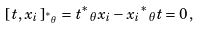Convert formula to latex. <formula><loc_0><loc_0><loc_500><loc_500>[ \, t , x _ { i } \, ] _ { { ^ { * } } _ { \theta } } = t { { ^ { * } } _ { \theta } } x _ { i } - x _ { i } { { ^ { * } } _ { \theta } } t = 0 \, ,</formula> 